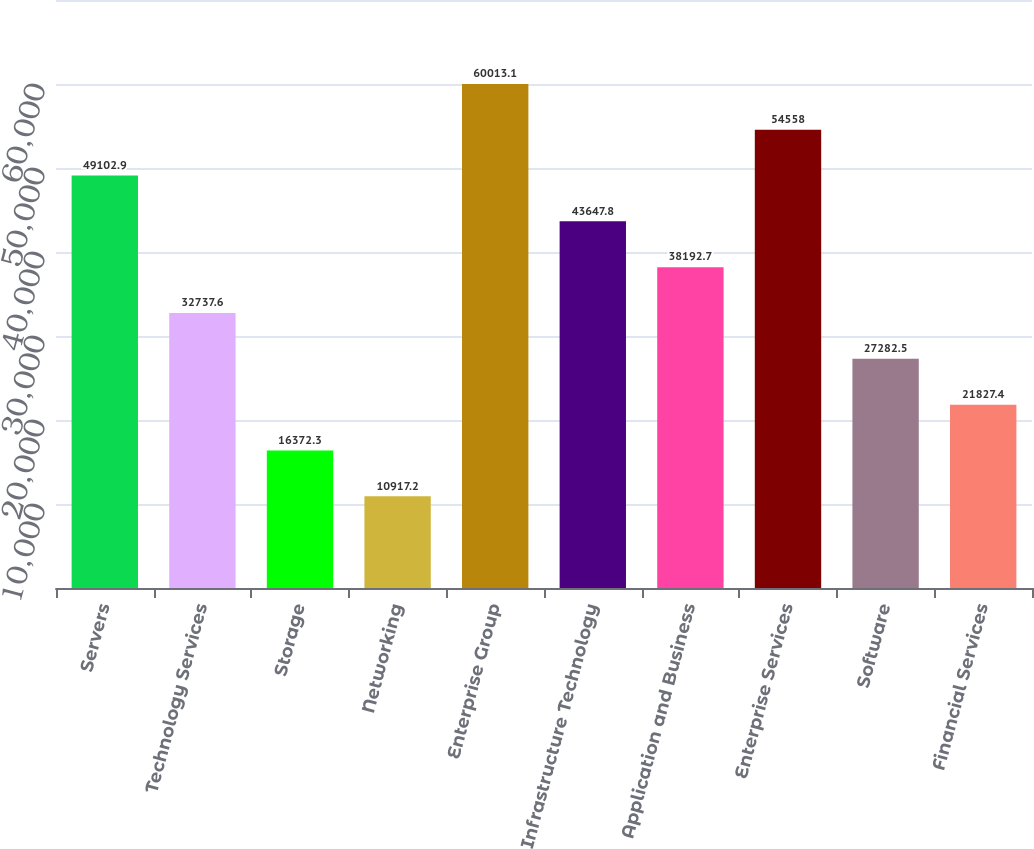Convert chart to OTSL. <chart><loc_0><loc_0><loc_500><loc_500><bar_chart><fcel>Servers<fcel>Technology Services<fcel>Storage<fcel>Networking<fcel>Enterprise Group<fcel>Infrastructure Technology<fcel>Application and Business<fcel>Enterprise Services<fcel>Software<fcel>Financial Services<nl><fcel>49102.9<fcel>32737.6<fcel>16372.3<fcel>10917.2<fcel>60013.1<fcel>43647.8<fcel>38192.7<fcel>54558<fcel>27282.5<fcel>21827.4<nl></chart> 